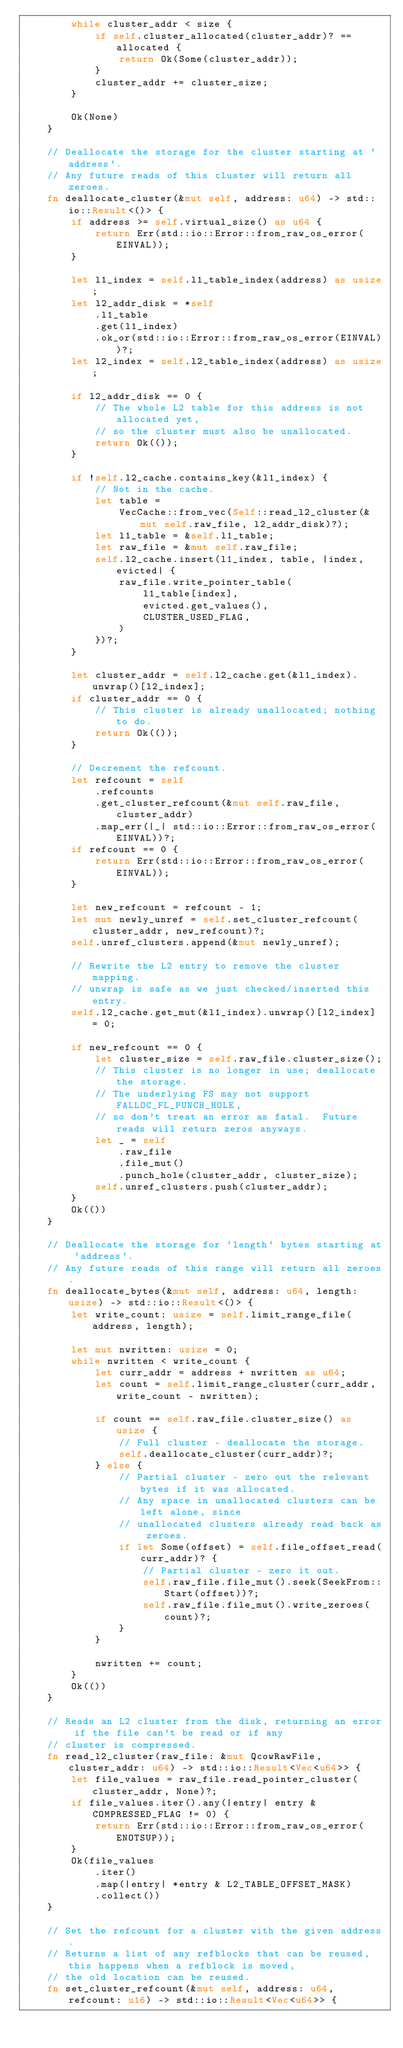<code> <loc_0><loc_0><loc_500><loc_500><_Rust_>        while cluster_addr < size {
            if self.cluster_allocated(cluster_addr)? == allocated {
                return Ok(Some(cluster_addr));
            }
            cluster_addr += cluster_size;
        }

        Ok(None)
    }

    // Deallocate the storage for the cluster starting at `address`.
    // Any future reads of this cluster will return all zeroes.
    fn deallocate_cluster(&mut self, address: u64) -> std::io::Result<()> {
        if address >= self.virtual_size() as u64 {
            return Err(std::io::Error::from_raw_os_error(EINVAL));
        }

        let l1_index = self.l1_table_index(address) as usize;
        let l2_addr_disk = *self
            .l1_table
            .get(l1_index)
            .ok_or(std::io::Error::from_raw_os_error(EINVAL))?;
        let l2_index = self.l2_table_index(address) as usize;

        if l2_addr_disk == 0 {
            // The whole L2 table for this address is not allocated yet,
            // so the cluster must also be unallocated.
            return Ok(());
        }

        if !self.l2_cache.contains_key(&l1_index) {
            // Not in the cache.
            let table =
                VecCache::from_vec(Self::read_l2_cluster(&mut self.raw_file, l2_addr_disk)?);
            let l1_table = &self.l1_table;
            let raw_file = &mut self.raw_file;
            self.l2_cache.insert(l1_index, table, |index, evicted| {
                raw_file.write_pointer_table(
                    l1_table[index],
                    evicted.get_values(),
                    CLUSTER_USED_FLAG,
                )
            })?;
        }

        let cluster_addr = self.l2_cache.get(&l1_index).unwrap()[l2_index];
        if cluster_addr == 0 {
            // This cluster is already unallocated; nothing to do.
            return Ok(());
        }

        // Decrement the refcount.
        let refcount = self
            .refcounts
            .get_cluster_refcount(&mut self.raw_file, cluster_addr)
            .map_err(|_| std::io::Error::from_raw_os_error(EINVAL))?;
        if refcount == 0 {
            return Err(std::io::Error::from_raw_os_error(EINVAL));
        }

        let new_refcount = refcount - 1;
        let mut newly_unref = self.set_cluster_refcount(cluster_addr, new_refcount)?;
        self.unref_clusters.append(&mut newly_unref);

        // Rewrite the L2 entry to remove the cluster mapping.
        // unwrap is safe as we just checked/inserted this entry.
        self.l2_cache.get_mut(&l1_index).unwrap()[l2_index] = 0;

        if new_refcount == 0 {
            let cluster_size = self.raw_file.cluster_size();
            // This cluster is no longer in use; deallocate the storage.
            // The underlying FS may not support FALLOC_FL_PUNCH_HOLE,
            // so don't treat an error as fatal.  Future reads will return zeros anyways.
            let _ = self
                .raw_file
                .file_mut()
                .punch_hole(cluster_addr, cluster_size);
            self.unref_clusters.push(cluster_addr);
        }
        Ok(())
    }

    // Deallocate the storage for `length` bytes starting at `address`.
    // Any future reads of this range will return all zeroes.
    fn deallocate_bytes(&mut self, address: u64, length: usize) -> std::io::Result<()> {
        let write_count: usize = self.limit_range_file(address, length);

        let mut nwritten: usize = 0;
        while nwritten < write_count {
            let curr_addr = address + nwritten as u64;
            let count = self.limit_range_cluster(curr_addr, write_count - nwritten);

            if count == self.raw_file.cluster_size() as usize {
                // Full cluster - deallocate the storage.
                self.deallocate_cluster(curr_addr)?;
            } else {
                // Partial cluster - zero out the relevant bytes if it was allocated.
                // Any space in unallocated clusters can be left alone, since
                // unallocated clusters already read back as zeroes.
                if let Some(offset) = self.file_offset_read(curr_addr)? {
                    // Partial cluster - zero it out.
                    self.raw_file.file_mut().seek(SeekFrom::Start(offset))?;
                    self.raw_file.file_mut().write_zeroes(count)?;
                }
            }

            nwritten += count;
        }
        Ok(())
    }

    // Reads an L2 cluster from the disk, returning an error if the file can't be read or if any
    // cluster is compressed.
    fn read_l2_cluster(raw_file: &mut QcowRawFile, cluster_addr: u64) -> std::io::Result<Vec<u64>> {
        let file_values = raw_file.read_pointer_cluster(cluster_addr, None)?;
        if file_values.iter().any(|entry| entry & COMPRESSED_FLAG != 0) {
            return Err(std::io::Error::from_raw_os_error(ENOTSUP));
        }
        Ok(file_values
            .iter()
            .map(|entry| *entry & L2_TABLE_OFFSET_MASK)
            .collect())
    }

    // Set the refcount for a cluster with the given address.
    // Returns a list of any refblocks that can be reused, this happens when a refblock is moved,
    // the old location can be reused.
    fn set_cluster_refcount(&mut self, address: u64, refcount: u16) -> std::io::Result<Vec<u64>> {</code> 